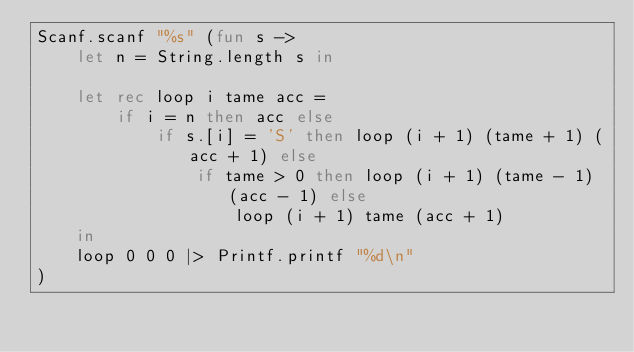<code> <loc_0><loc_0><loc_500><loc_500><_OCaml_>Scanf.scanf "%s" (fun s ->
    let n = String.length s in

    let rec loop i tame acc =
        if i = n then acc else
            if s.[i] = 'S' then loop (i + 1) (tame + 1) (acc + 1) else
                if tame > 0 then loop (i + 1) (tame - 1) (acc - 1) else
                    loop (i + 1) tame (acc + 1)
    in
    loop 0 0 0 |> Printf.printf "%d\n"
)</code> 